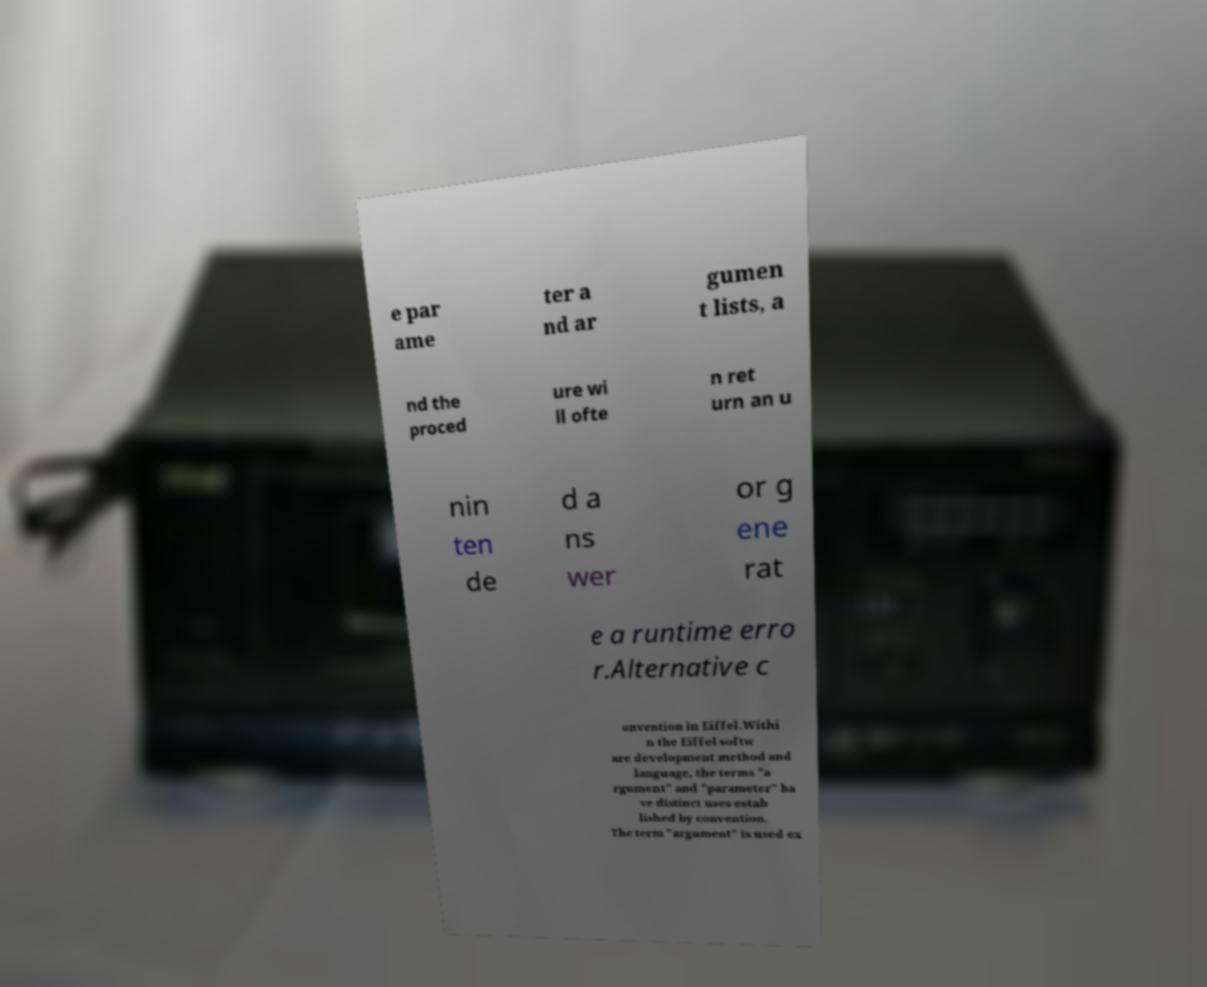Can you accurately transcribe the text from the provided image for me? e par ame ter a nd ar gumen t lists, a nd the proced ure wi ll ofte n ret urn an u nin ten de d a ns wer or g ene rat e a runtime erro r.Alternative c onvention in Eiffel.Withi n the Eiffel softw are development method and language, the terms "a rgument" and "parameter" ha ve distinct uses estab lished by convention. The term "argument" is used ex 